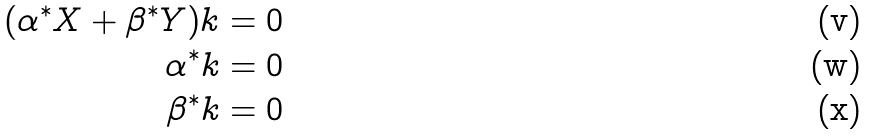<formula> <loc_0><loc_0><loc_500><loc_500>( \alpha ^ { * } X + \beta ^ { * } Y ) k & = 0 \\ \alpha ^ { * } k & = 0 \\ \beta ^ { * } k & = 0</formula> 